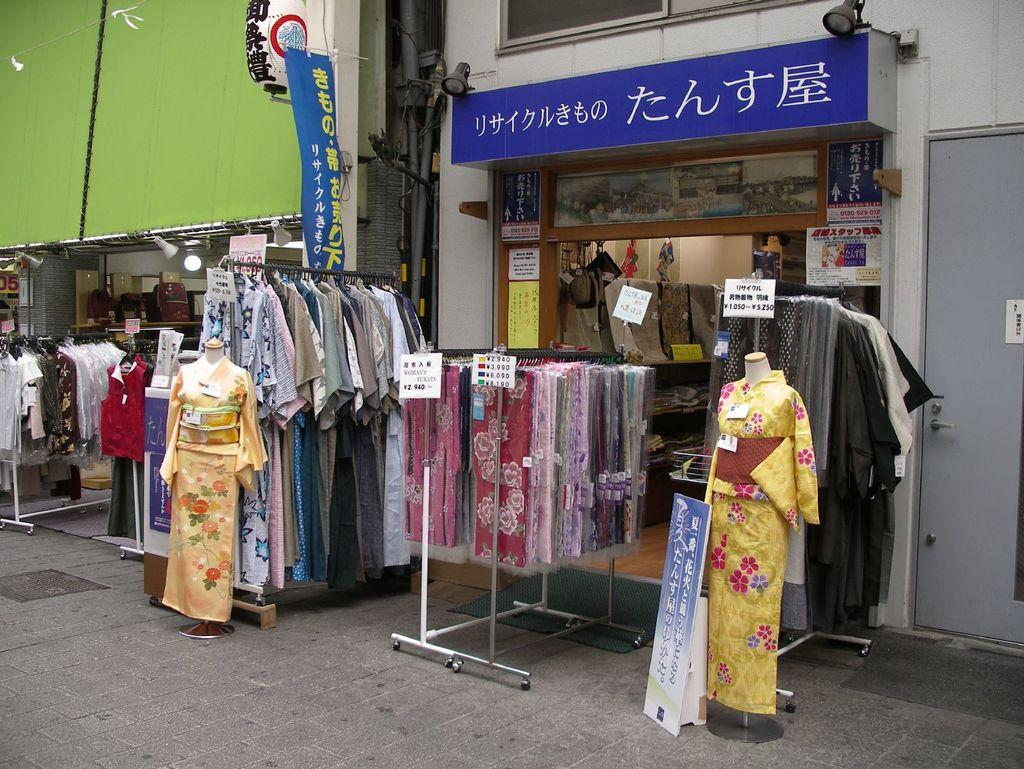What type of establishment is shown in the image? There is a clothes shop in the image. How are the clothes displayed outside the shop? Clothes are displayed on a stand outside the shop. What are the hangers used for in the image? Hangers are present outside the shop, likely for displaying or organizing the clothes. Are there any other similar establishments visible in the image? Yes, there are other clothes shops visible in the image. What type of letters are being washed in the image? There are no letters or washing activities present in the image; it features a clothes shop with clothes displayed outside. 